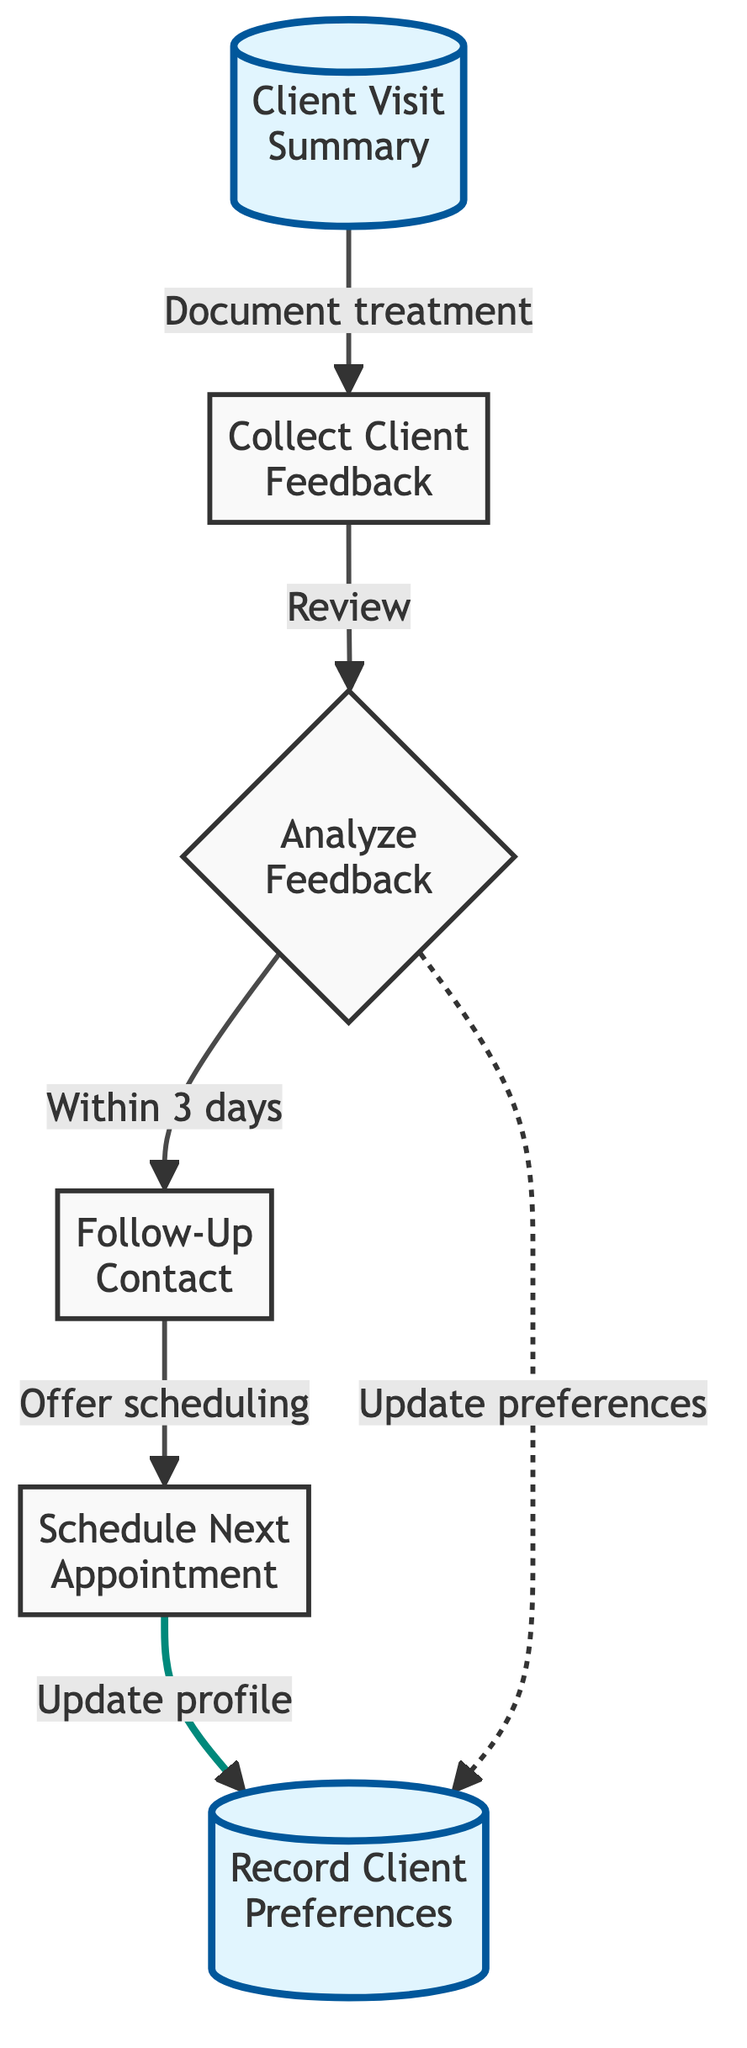What is the first step in the flowchart? The first step in the flowchart is "Client Visit Summary." This is evident as it is the initial node in the diagram, indicating that it is the starting point for the process.
Answer: Client Visit Summary How many nodes are in the flowchart? Counting all distinct steps depicted, we find there are 6 nodes shown in the flowchart. Each node represents a different stage in the client feedback and follow-up process.
Answer: 6 What is the action taken after collecting client feedback? After collecting client feedback, the flowchart indicates that the next action is to "Analyze Feedback." This is a direct transition from the feedback collection node to the analysis.
Answer: Analyze Feedback What type of feedback method is used? The feedback method specified in the diagram is a "feedback form" provided to the client post-treatment, indicating a structured way to gather client opinions.
Answer: Feedback form How soon is the follow-up contact made after analyzing feedback? The diagram specifies that the follow-up contact occurs "within 3 days" after the feedback has been analyzed, indicating prompt communication with the client.
Answer: Within 3 days What happens to the client profile after scheduling the next appointment? After scheduling the next appointment, the next step shown in the flowchart states that the client's profile is then updated with any feedback and special requests that were noted.
Answer: Update profile What is the relationship between analyzing feedback and updating client preferences? The flowchart shows that analyzing feedback allows for either a direct output to "Record Client Preferences" or an update to it, denoting that feedback directly influences client profile adjustments.
Answer: Direct influence What step precedes scheduling the next appointment? Before scheduling the next appointment, the follow-up contact has to occur, ensuring that the client is engaged again before planning future treatments.
Answer: Follow-Up Contact 